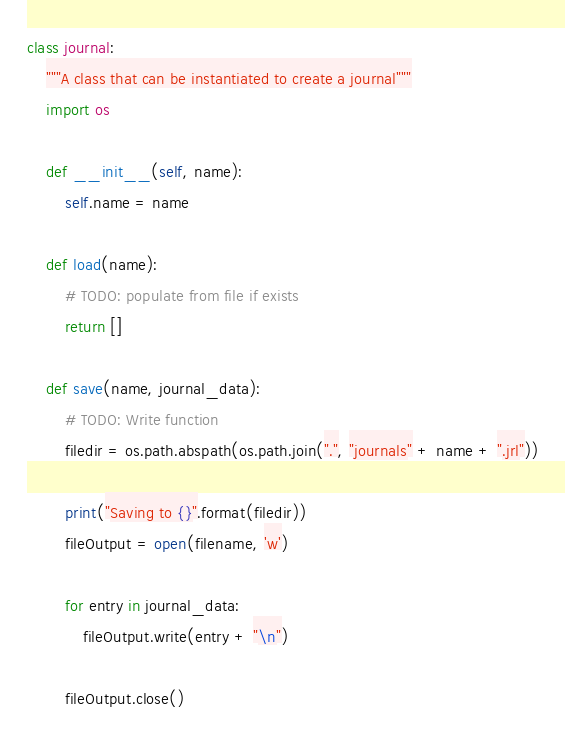Convert code to text. <code><loc_0><loc_0><loc_500><loc_500><_Python_>

class journal:
    """A class that can be instantiated to create a journal"""
    import os

    def __init__(self, name):
        self.name = name

    def load(name):
        # TODO: populate from file if exists
        return []

    def save(name, journal_data):
        # TODO: Write function
        filedir = os.path.abspath(os.path.join(".", "journals" + name + ".jrl"))

        print("Saving to {}".format(filedir))
        fileOutput = open(filename, 'w')

        for entry in journal_data:
            fileOutput.write(entry + "\n")

        fileOutput.close()
</code> 